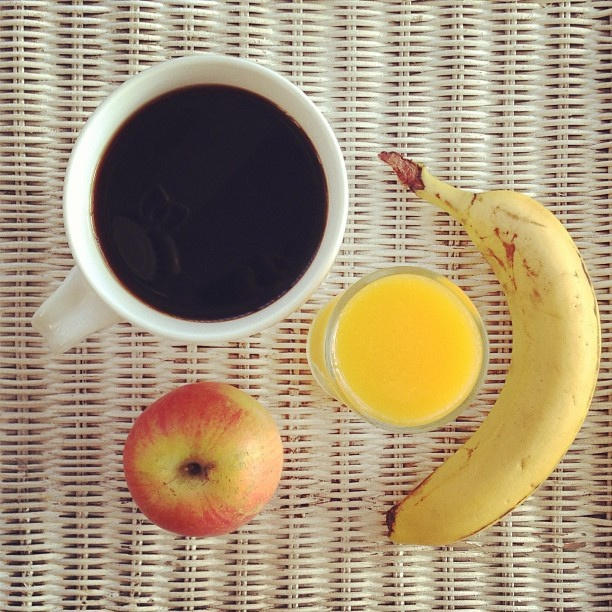Describe the objects in this image and their specific colors. I can see cup in gray, black, ivory, tan, and lightgray tones, banana in gray, tan, and khaki tones, cup in gray, gold, and tan tones, and apple in gray, tan, and brown tones in this image. 